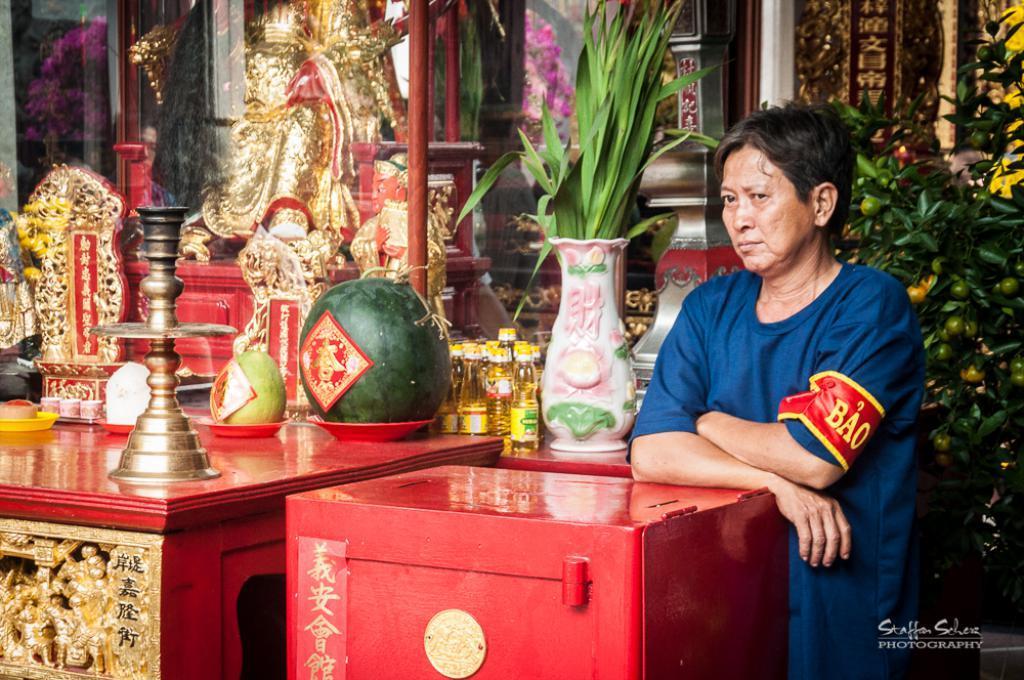How would you summarize this image in a sentence or two? In the image we can see there is a person who is standing and in front of her there is red colour box and beside her there is fruits in a plate, oil bottles, vase in which there are plants kept and there is a statue of a person. 